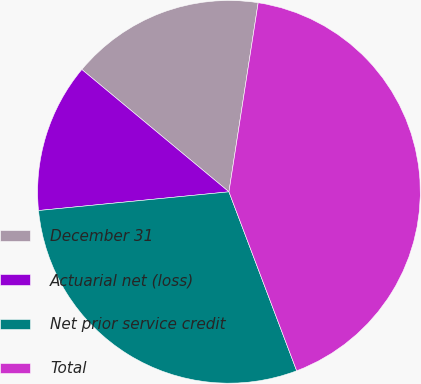<chart> <loc_0><loc_0><loc_500><loc_500><pie_chart><fcel>December 31<fcel>Actuarial net (loss)<fcel>Net prior service credit<fcel>Total<nl><fcel>16.4%<fcel>12.6%<fcel>29.2%<fcel>41.8%<nl></chart> 